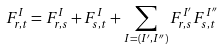<formula> <loc_0><loc_0><loc_500><loc_500>F _ { r , t } ^ { I } = F _ { r , s } ^ { I } + F _ { s , t } ^ { I } + \sum _ { I = ( I ^ { \prime } , I ^ { \prime \prime } ) } F _ { r , s } ^ { I ^ { \prime } } F _ { s , t } ^ { I ^ { \prime \prime } }</formula> 